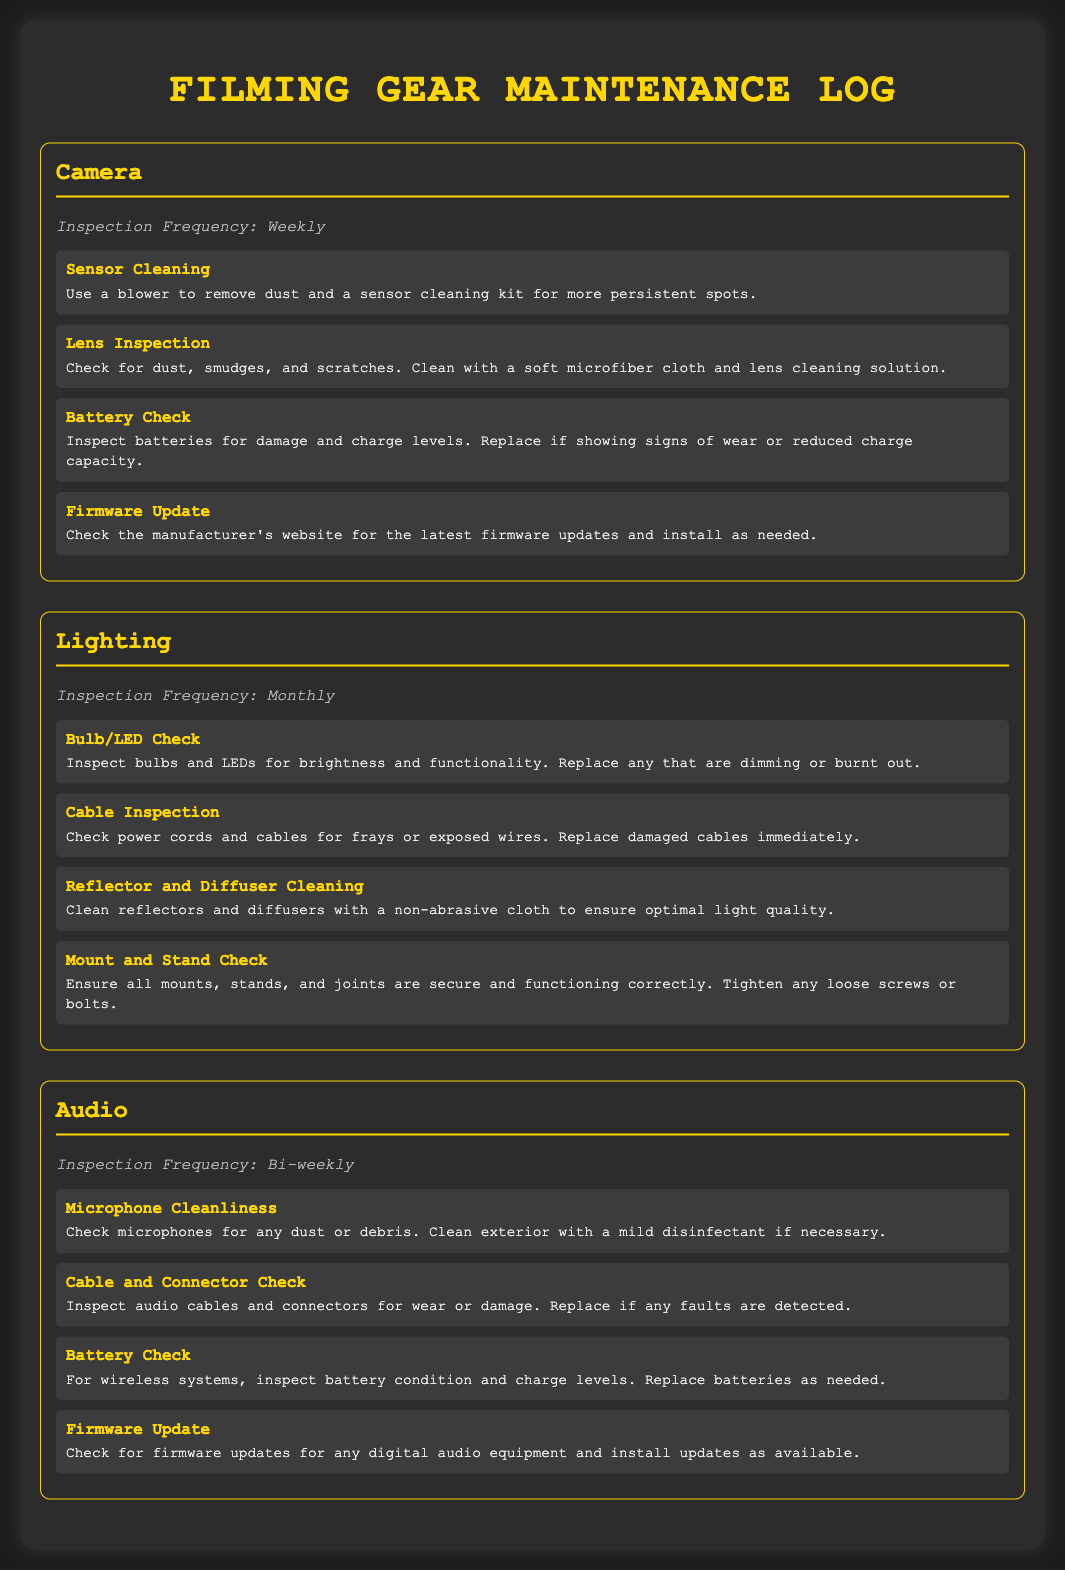what is the inspection frequency for Camera? The inspection frequency is mentioned in the camera section of the document as "Weekly."
Answer: Weekly what are the tasks listed under Lighting maintenance? The tasks include checking bulbs/LEDs, inspecting cables, cleaning reflectors and diffusers, and checking mounts and stands.
Answer: Bulb/LED Check, Cable Inspection, Reflector and Diffuser Cleaning, Mount and Stand Check how often should the audio equipment be checked? The audio section specifies that it should be checked "Bi-weekly."
Answer: Bi-weekly what is the task for Sensor Cleaning? The task details for Sensor Cleaning are included in the camera section specifying the method for cleaning the sensor.
Answer: Use a blower to remove dust and a sensor cleaning kit for more persistent spots which equipment requires monthly inspection? The document specifies that "Lighting" equipment requires monthly inspection.
Answer: Lighting what is the task mentioned for Battery Check in Audio? The task details about Battery Check for Audio mention inspecting battery condition and charge levels.
Answer: Inspect battery condition and charge levels 